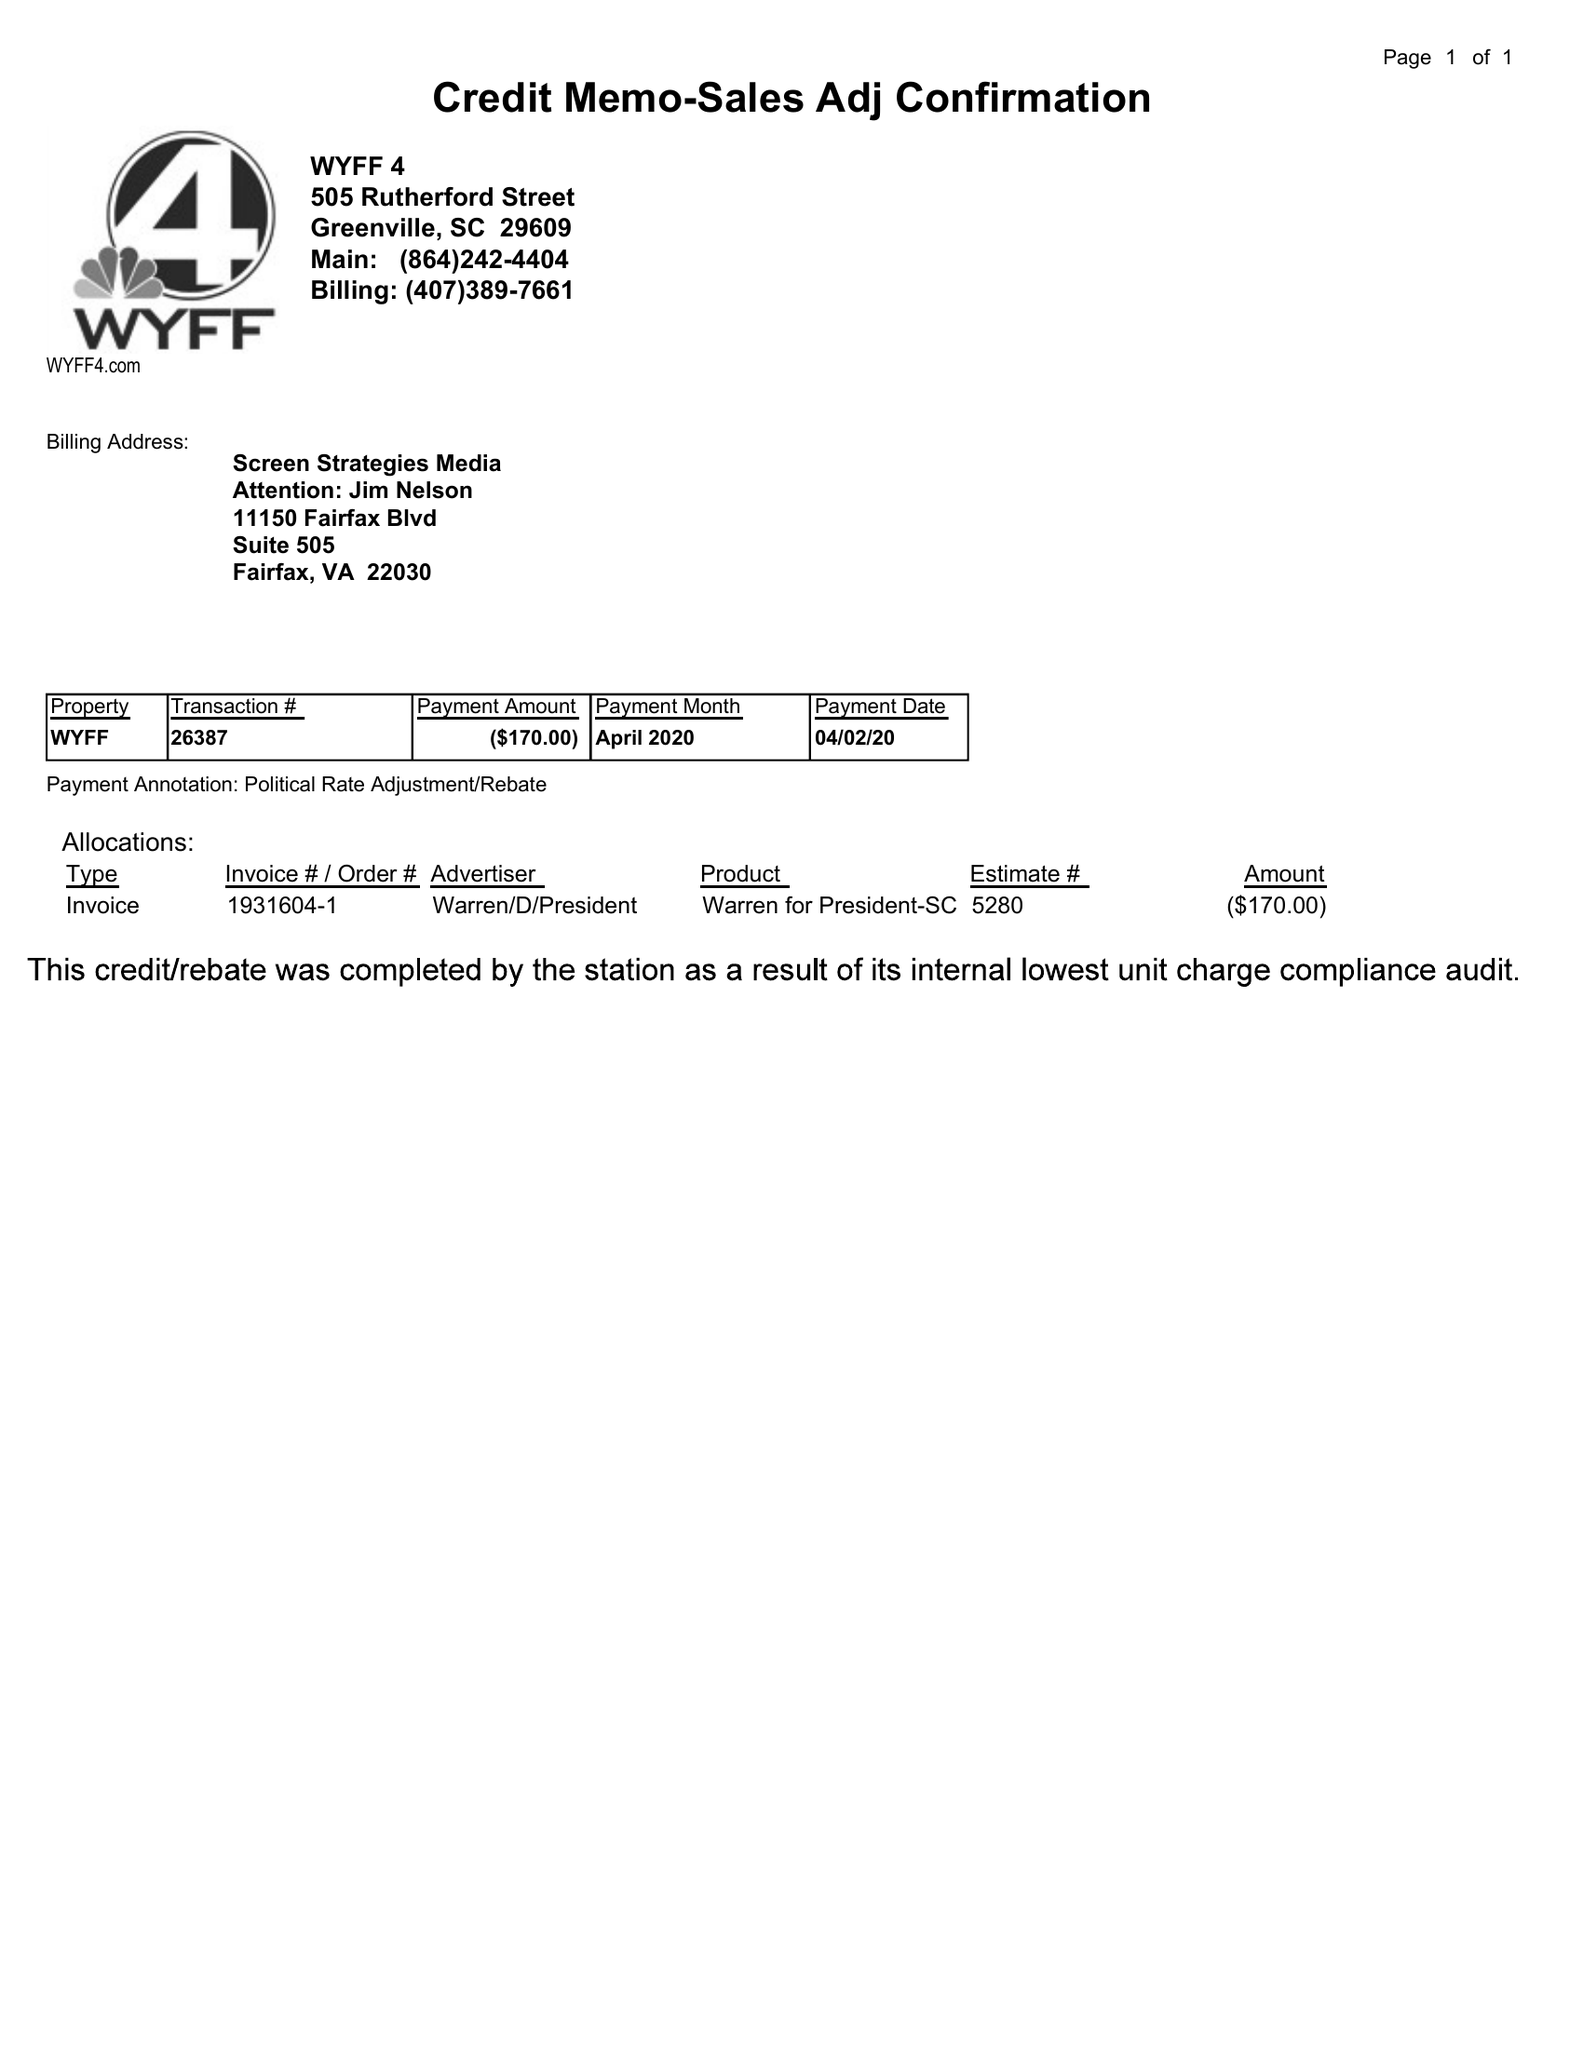What is the value for the flight_from?
Answer the question using a single word or phrase. None 